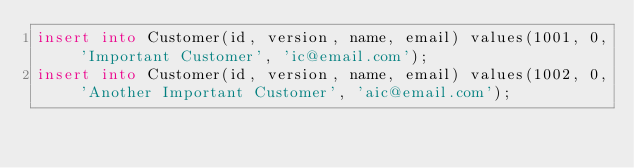Convert code to text. <code><loc_0><loc_0><loc_500><loc_500><_SQL_>insert into Customer(id, version, name, email) values(1001, 0, 'Important Customer', 'ic@email.com');
insert into Customer(id, version, name, email) values(1002, 0, 'Another Important Customer', 'aic@email.com');</code> 